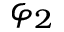<formula> <loc_0><loc_0><loc_500><loc_500>\varphi _ { 2 }</formula> 